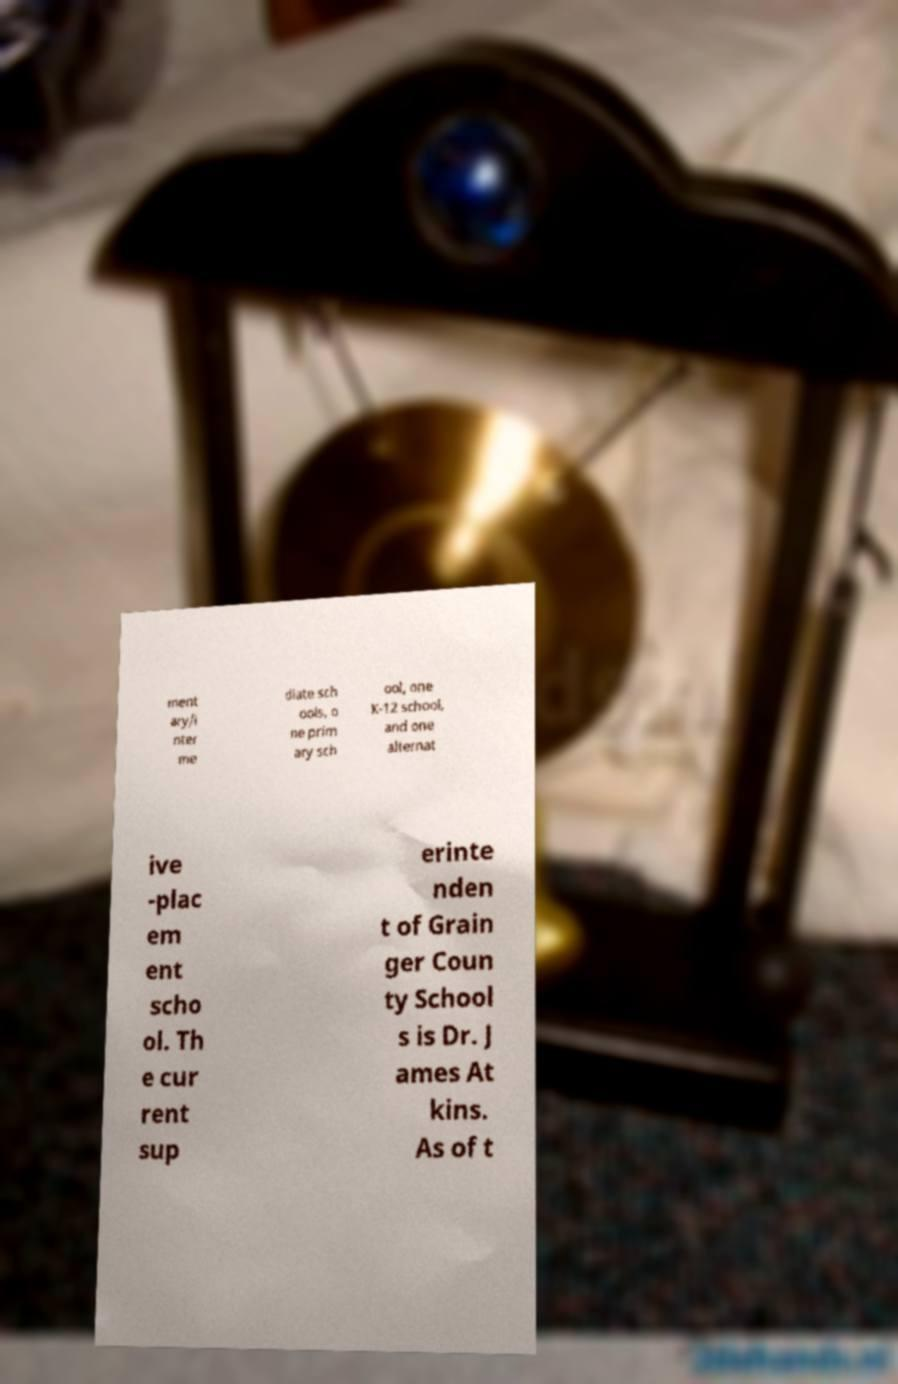What messages or text are displayed in this image? I need them in a readable, typed format. ment ary/i nter me diate sch ools, o ne prim ary sch ool, one K-12 school, and one alternat ive -plac em ent scho ol. Th e cur rent sup erinte nden t of Grain ger Coun ty School s is Dr. J ames At kins. As of t 